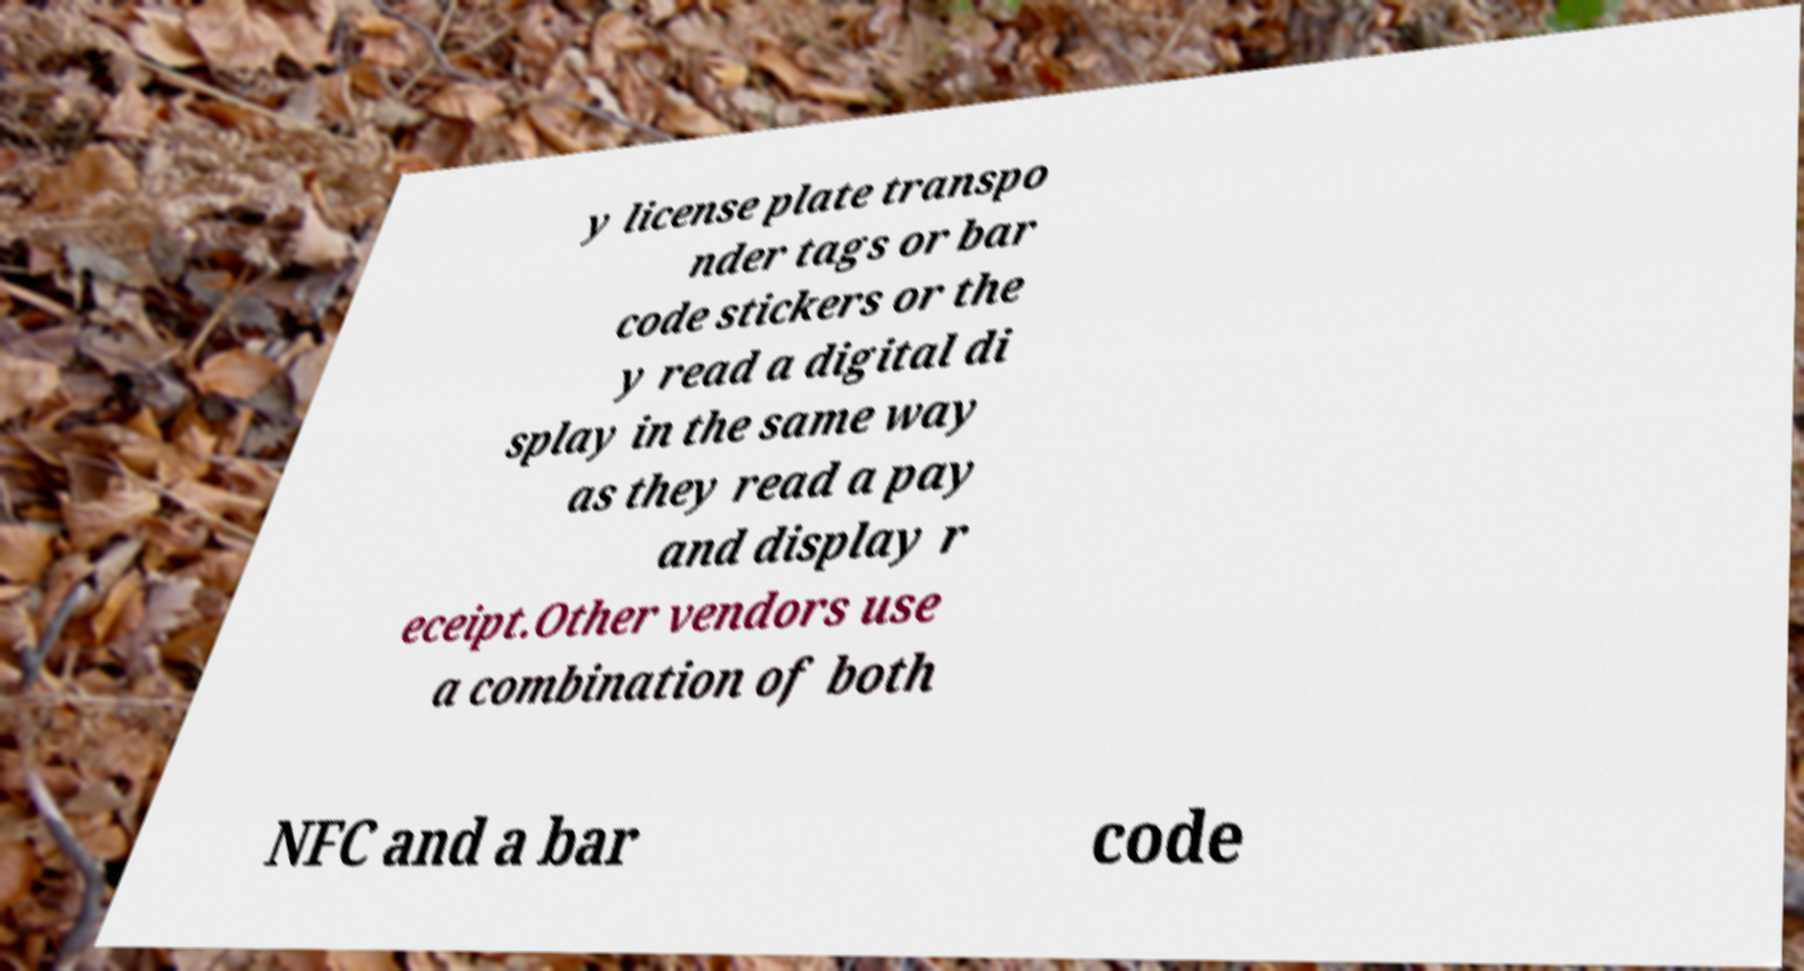Could you extract and type out the text from this image? y license plate transpo nder tags or bar code stickers or the y read a digital di splay in the same way as they read a pay and display r eceipt.Other vendors use a combination of both NFC and a bar code 